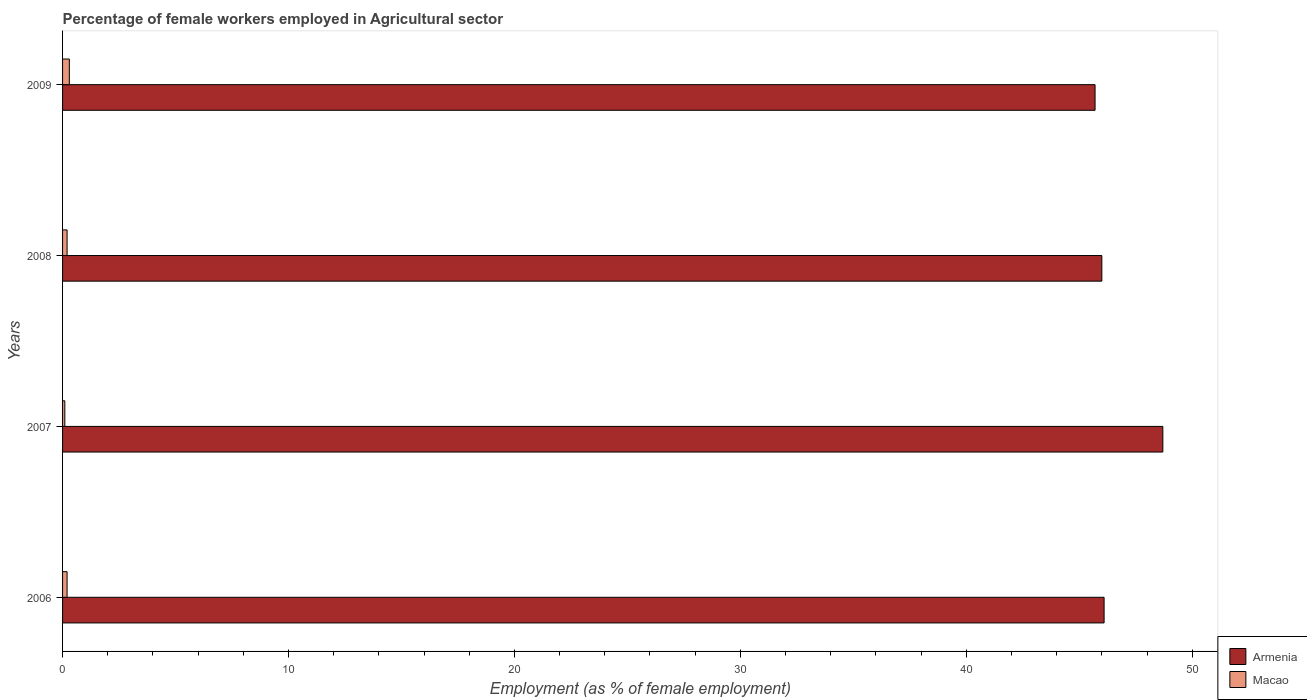How many groups of bars are there?
Your response must be concise. 4. What is the label of the 4th group of bars from the top?
Give a very brief answer. 2006. In how many cases, is the number of bars for a given year not equal to the number of legend labels?
Offer a terse response. 0. What is the percentage of females employed in Agricultural sector in Macao in 2008?
Make the answer very short. 0.2. Across all years, what is the maximum percentage of females employed in Agricultural sector in Macao?
Provide a succinct answer. 0.3. Across all years, what is the minimum percentage of females employed in Agricultural sector in Macao?
Your answer should be compact. 0.1. What is the total percentage of females employed in Agricultural sector in Armenia in the graph?
Ensure brevity in your answer.  186.5. What is the difference between the percentage of females employed in Agricultural sector in Armenia in 2006 and that in 2007?
Give a very brief answer. -2.6. What is the difference between the percentage of females employed in Agricultural sector in Armenia in 2009 and the percentage of females employed in Agricultural sector in Macao in 2008?
Make the answer very short. 45.5. What is the average percentage of females employed in Agricultural sector in Macao per year?
Keep it short and to the point. 0.2. In the year 2009, what is the difference between the percentage of females employed in Agricultural sector in Macao and percentage of females employed in Agricultural sector in Armenia?
Your answer should be very brief. -45.4. In how many years, is the percentage of females employed in Agricultural sector in Armenia greater than 28 %?
Give a very brief answer. 4. What is the ratio of the percentage of females employed in Agricultural sector in Armenia in 2006 to that in 2007?
Provide a succinct answer. 0.95. Is the percentage of females employed in Agricultural sector in Macao in 2007 less than that in 2008?
Offer a very short reply. Yes. Is the difference between the percentage of females employed in Agricultural sector in Macao in 2008 and 2009 greater than the difference between the percentage of females employed in Agricultural sector in Armenia in 2008 and 2009?
Give a very brief answer. No. What is the difference between the highest and the second highest percentage of females employed in Agricultural sector in Armenia?
Make the answer very short. 2.6. In how many years, is the percentage of females employed in Agricultural sector in Macao greater than the average percentage of females employed in Agricultural sector in Macao taken over all years?
Your response must be concise. 1. What does the 2nd bar from the top in 2009 represents?
Provide a short and direct response. Armenia. What does the 2nd bar from the bottom in 2006 represents?
Give a very brief answer. Macao. How many bars are there?
Your answer should be compact. 8. Are all the bars in the graph horizontal?
Keep it short and to the point. Yes. How many years are there in the graph?
Offer a very short reply. 4. What is the difference between two consecutive major ticks on the X-axis?
Provide a succinct answer. 10. Does the graph contain grids?
Make the answer very short. No. Where does the legend appear in the graph?
Offer a very short reply. Bottom right. How many legend labels are there?
Your answer should be compact. 2. How are the legend labels stacked?
Give a very brief answer. Vertical. What is the title of the graph?
Make the answer very short. Percentage of female workers employed in Agricultural sector. What is the label or title of the X-axis?
Give a very brief answer. Employment (as % of female employment). What is the Employment (as % of female employment) of Armenia in 2006?
Your answer should be very brief. 46.1. What is the Employment (as % of female employment) in Macao in 2006?
Your answer should be very brief. 0.2. What is the Employment (as % of female employment) of Armenia in 2007?
Your response must be concise. 48.7. What is the Employment (as % of female employment) of Macao in 2007?
Your response must be concise. 0.1. What is the Employment (as % of female employment) in Macao in 2008?
Offer a terse response. 0.2. What is the Employment (as % of female employment) in Armenia in 2009?
Provide a short and direct response. 45.7. What is the Employment (as % of female employment) of Macao in 2009?
Provide a short and direct response. 0.3. Across all years, what is the maximum Employment (as % of female employment) in Armenia?
Your answer should be compact. 48.7. Across all years, what is the maximum Employment (as % of female employment) in Macao?
Provide a succinct answer. 0.3. Across all years, what is the minimum Employment (as % of female employment) of Armenia?
Your answer should be very brief. 45.7. Across all years, what is the minimum Employment (as % of female employment) of Macao?
Offer a very short reply. 0.1. What is the total Employment (as % of female employment) in Armenia in the graph?
Give a very brief answer. 186.5. What is the total Employment (as % of female employment) in Macao in the graph?
Offer a very short reply. 0.8. What is the difference between the Employment (as % of female employment) in Macao in 2007 and that in 2008?
Ensure brevity in your answer.  -0.1. What is the difference between the Employment (as % of female employment) in Armenia in 2007 and that in 2009?
Ensure brevity in your answer.  3. What is the difference between the Employment (as % of female employment) in Armenia in 2008 and that in 2009?
Your answer should be compact. 0.3. What is the difference between the Employment (as % of female employment) in Armenia in 2006 and the Employment (as % of female employment) in Macao in 2007?
Provide a short and direct response. 46. What is the difference between the Employment (as % of female employment) of Armenia in 2006 and the Employment (as % of female employment) of Macao in 2008?
Provide a succinct answer. 45.9. What is the difference between the Employment (as % of female employment) in Armenia in 2006 and the Employment (as % of female employment) in Macao in 2009?
Offer a very short reply. 45.8. What is the difference between the Employment (as % of female employment) in Armenia in 2007 and the Employment (as % of female employment) in Macao in 2008?
Ensure brevity in your answer.  48.5. What is the difference between the Employment (as % of female employment) in Armenia in 2007 and the Employment (as % of female employment) in Macao in 2009?
Your response must be concise. 48.4. What is the difference between the Employment (as % of female employment) of Armenia in 2008 and the Employment (as % of female employment) of Macao in 2009?
Offer a very short reply. 45.7. What is the average Employment (as % of female employment) of Armenia per year?
Offer a very short reply. 46.62. In the year 2006, what is the difference between the Employment (as % of female employment) in Armenia and Employment (as % of female employment) in Macao?
Your answer should be compact. 45.9. In the year 2007, what is the difference between the Employment (as % of female employment) of Armenia and Employment (as % of female employment) of Macao?
Offer a very short reply. 48.6. In the year 2008, what is the difference between the Employment (as % of female employment) of Armenia and Employment (as % of female employment) of Macao?
Offer a very short reply. 45.8. In the year 2009, what is the difference between the Employment (as % of female employment) of Armenia and Employment (as % of female employment) of Macao?
Your answer should be compact. 45.4. What is the ratio of the Employment (as % of female employment) of Armenia in 2006 to that in 2007?
Provide a succinct answer. 0.95. What is the ratio of the Employment (as % of female employment) of Macao in 2006 to that in 2008?
Your answer should be compact. 1. What is the ratio of the Employment (as % of female employment) in Armenia in 2006 to that in 2009?
Make the answer very short. 1.01. What is the ratio of the Employment (as % of female employment) of Macao in 2006 to that in 2009?
Give a very brief answer. 0.67. What is the ratio of the Employment (as % of female employment) of Armenia in 2007 to that in 2008?
Keep it short and to the point. 1.06. What is the ratio of the Employment (as % of female employment) in Macao in 2007 to that in 2008?
Make the answer very short. 0.5. What is the ratio of the Employment (as % of female employment) in Armenia in 2007 to that in 2009?
Offer a very short reply. 1.07. What is the ratio of the Employment (as % of female employment) in Armenia in 2008 to that in 2009?
Offer a very short reply. 1.01. What is the difference between the highest and the second highest Employment (as % of female employment) of Armenia?
Provide a short and direct response. 2.6. What is the difference between the highest and the second highest Employment (as % of female employment) of Macao?
Your answer should be very brief. 0.1. What is the difference between the highest and the lowest Employment (as % of female employment) of Armenia?
Give a very brief answer. 3. What is the difference between the highest and the lowest Employment (as % of female employment) in Macao?
Keep it short and to the point. 0.2. 